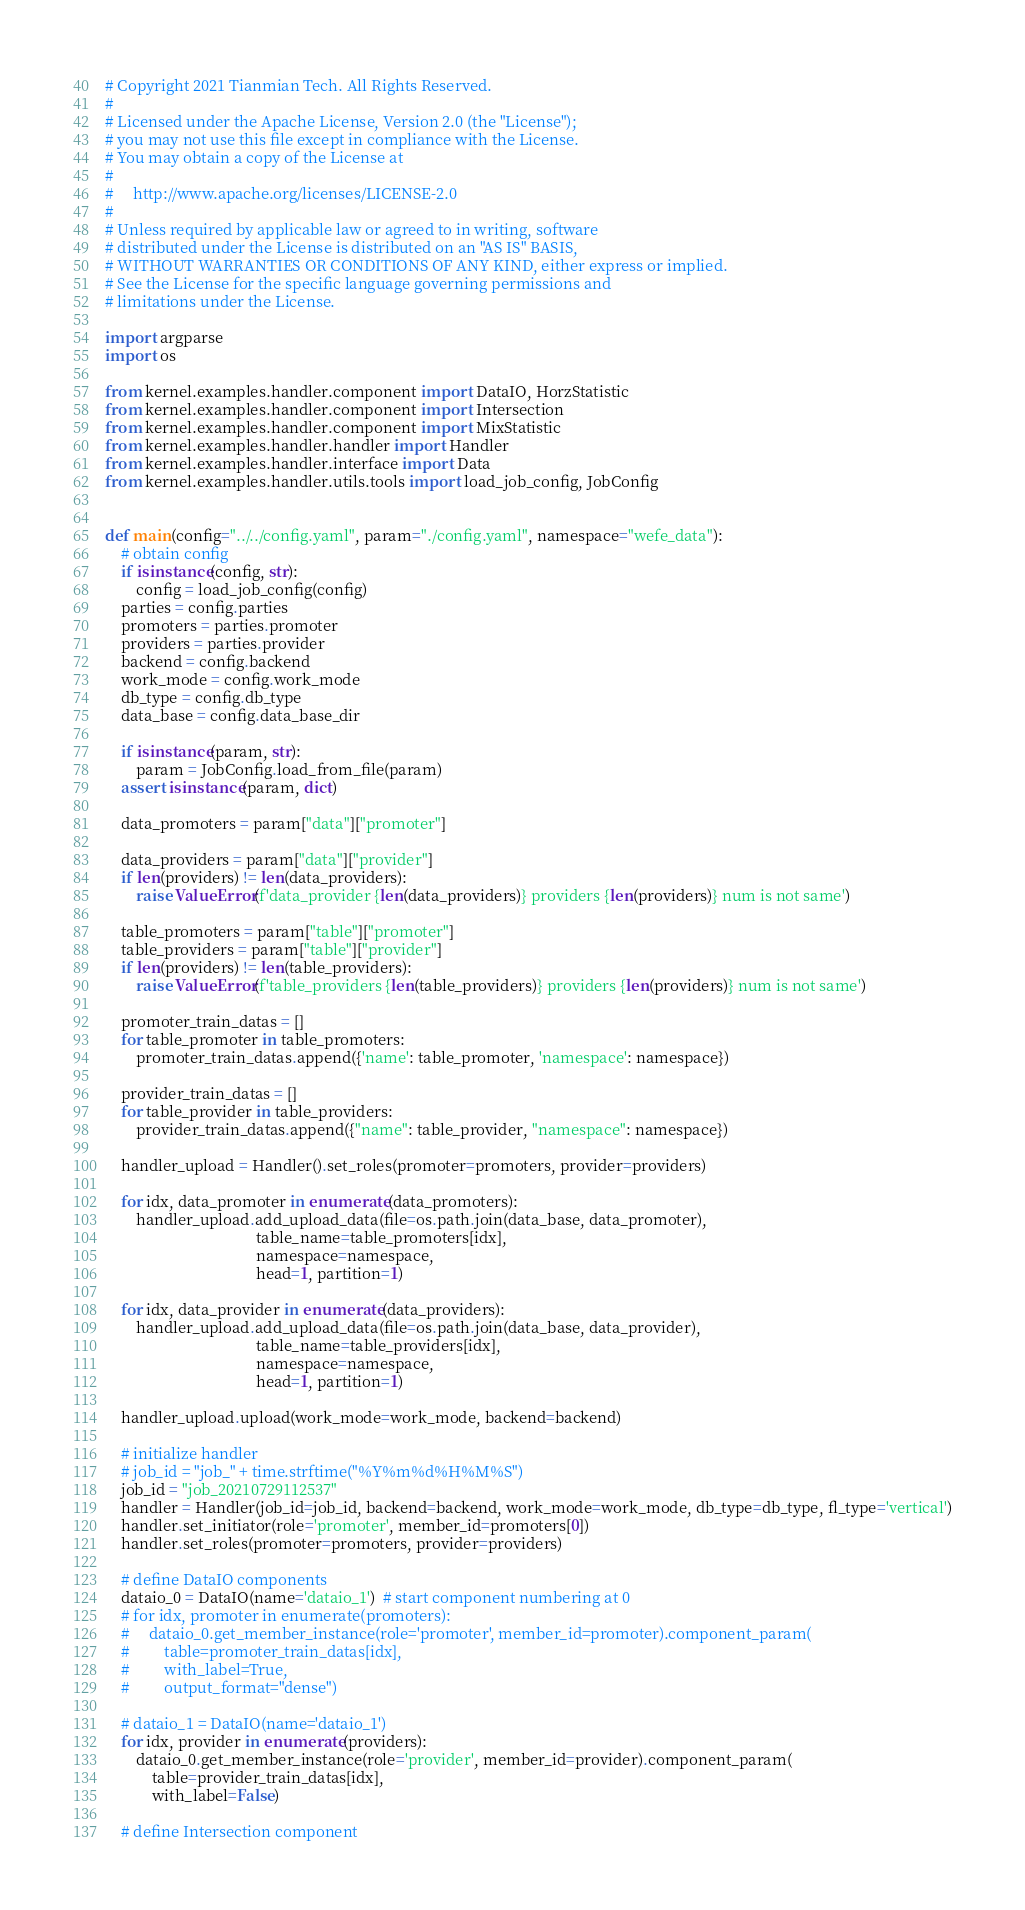Convert code to text. <code><loc_0><loc_0><loc_500><loc_500><_Python_># Copyright 2021 Tianmian Tech. All Rights Reserved.
# 
# Licensed under the Apache License, Version 2.0 (the "License");
# you may not use this file except in compliance with the License.
# You may obtain a copy of the License at
# 
#     http://www.apache.org/licenses/LICENSE-2.0
# 
# Unless required by applicable law or agreed to in writing, software
# distributed under the License is distributed on an "AS IS" BASIS,
# WITHOUT WARRANTIES OR CONDITIONS OF ANY KIND, either express or implied.
# See the License for the specific language governing permissions and
# limitations under the License.

import argparse
import os

from kernel.examples.handler.component import DataIO, HorzStatistic
from kernel.examples.handler.component import Intersection
from kernel.examples.handler.component import MixStatistic
from kernel.examples.handler.handler import Handler
from kernel.examples.handler.interface import Data
from kernel.examples.handler.utils.tools import load_job_config, JobConfig


def main(config="../../config.yaml", param="./config.yaml", namespace="wefe_data"):
    # obtain config
    if isinstance(config, str):
        config = load_job_config(config)
    parties = config.parties
    promoters = parties.promoter
    providers = parties.provider
    backend = config.backend
    work_mode = config.work_mode
    db_type = config.db_type
    data_base = config.data_base_dir

    if isinstance(param, str):
        param = JobConfig.load_from_file(param)
    assert isinstance(param, dict)

    data_promoters = param["data"]["promoter"]

    data_providers = param["data"]["provider"]
    if len(providers) != len(data_providers):
        raise ValueError(f'data_provider {len(data_providers)} providers {len(providers)} num is not same')

    table_promoters = param["table"]["promoter"]
    table_providers = param["table"]["provider"]
    if len(providers) != len(table_providers):
        raise ValueError(f'table_providers {len(table_providers)} providers {len(providers)} num is not same')

    promoter_train_datas = []
    for table_promoter in table_promoters:
        promoter_train_datas.append({'name': table_promoter, 'namespace': namespace})

    provider_train_datas = []
    for table_provider in table_providers:
        provider_train_datas.append({"name": table_provider, "namespace": namespace})

    handler_upload = Handler().set_roles(promoter=promoters, provider=providers)

    for idx, data_promoter in enumerate(data_promoters):
        handler_upload.add_upload_data(file=os.path.join(data_base, data_promoter),
                                       table_name=table_promoters[idx],
                                       namespace=namespace,
                                       head=1, partition=1)

    for idx, data_provider in enumerate(data_providers):
        handler_upload.add_upload_data(file=os.path.join(data_base, data_provider),
                                       table_name=table_providers[idx],
                                       namespace=namespace,
                                       head=1, partition=1)

    handler_upload.upload(work_mode=work_mode, backend=backend)

    # initialize handler
    # job_id = "job_" + time.strftime("%Y%m%d%H%M%S")
    job_id = "job_20210729112537"
    handler = Handler(job_id=job_id, backend=backend, work_mode=work_mode, db_type=db_type, fl_type='vertical')
    handler.set_initiator(role='promoter', member_id=promoters[0])
    handler.set_roles(promoter=promoters, provider=providers)

    # define DataIO components
    dataio_0 = DataIO(name='dataio_1')  # start component numbering at 0
    # for idx, promoter in enumerate(promoters):
    #     dataio_0.get_member_instance(role='promoter', member_id=promoter).component_param(
    #         table=promoter_train_datas[idx],
    #         with_label=True,
    #         output_format="dense")

    # dataio_1 = DataIO(name='dataio_1')
    for idx, provider in enumerate(providers):
        dataio_0.get_member_instance(role='provider', member_id=provider).component_param(
            table=provider_train_datas[idx],
            with_label=False)

    # define Intersection component</code> 